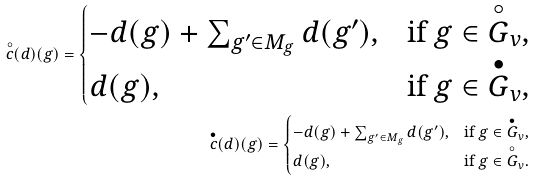Convert formula to latex. <formula><loc_0><loc_0><loc_500><loc_500>\overset { \circ } { c } ( d ) ( g ) = \begin{cases} - d ( g ) + \sum _ { g ^ { \prime } \in M _ { g } } d ( g ^ { \prime } ) , & \text {if} \ g \in \overset { \circ } { G } _ { v } , \\ d ( g ) , & \text {if} \ g \in \overset { \bullet } { G } _ { v } , \end{cases} \\ \overset { \bullet } { c } ( d ) ( g ) = \begin{cases} - d ( g ) + \sum _ { g ^ { \prime } \in M _ { g } } d ( g ^ { \prime } ) , & \text {if} \ g \in \overset { \bullet } { G } _ { v } , \\ d ( g ) , & \text {if} \ g \in \overset { \circ } { G } _ { v } . \end{cases}</formula> 